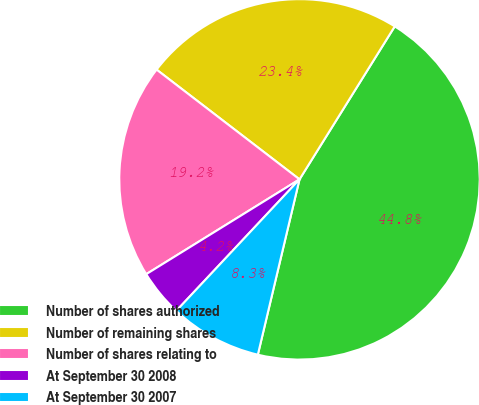Convert chart to OTSL. <chart><loc_0><loc_0><loc_500><loc_500><pie_chart><fcel>Number of shares authorized<fcel>Number of remaining shares<fcel>Number of shares relating to<fcel>At September 30 2008<fcel>At September 30 2007<nl><fcel>44.85%<fcel>23.44%<fcel>19.24%<fcel>4.2%<fcel>8.27%<nl></chart> 